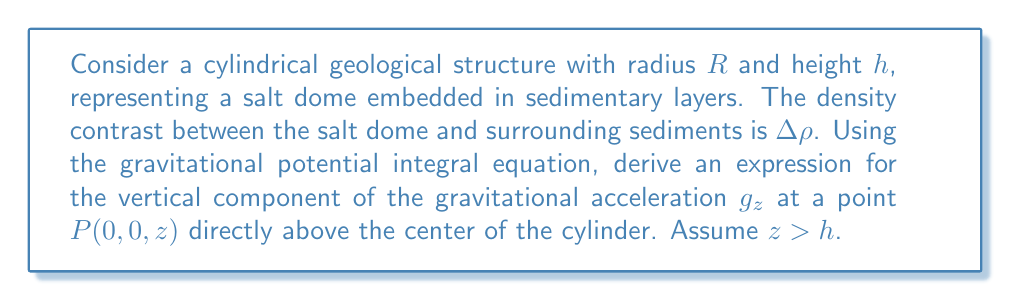Give your solution to this math problem. 1) The gravitational potential $U$ at point $P$ due to a mass distribution is given by:

   $$U = G \int_V \frac{\Delta\rho}{r} dV$$

   where $G$ is the gravitational constant, $V$ is the volume of the cylinder, and $r$ is the distance from a point in the cylinder to $P$.

2) For a cylinder, we can use cylindrical coordinates $(r', \theta, z')$:

   $$U = G\Delta\rho \int_0^h \int_0^R \int_0^{2\pi} \frac{r'}{[(z-z')^2 + r'^2]^{1/2}} d\theta dr' dz'$$

3) The vertical component of gravitational acceleration $g_z$ is given by:

   $$g_z = -\frac{\partial U}{\partial z}$$

4) Differentiating under the integral sign:

   $$g_z = G\Delta\rho \int_0^h \int_0^R \int_0^{2\pi} \frac{z-z'}{[(z-z')^2 + r'^2]^{3/2}} r' d\theta dr' dz'$$

5) Integrate with respect to $\theta$:

   $$g_z = 2\pi G\Delta\rho \int_0^h \int_0^R \frac{z-z'}{[(z-z')^2 + r'^2]^{3/2}} r' dr' dz'$$

6) Integrate with respect to $r'$:

   $$g_z = 2\pi G\Delta\rho \int_0^h \left[1 - \frac{z-z'}{\sqrt{(z-z')^2 + R^2}}\right] dz'$$

7) Finally, integrate with respect to $z'$:

   $$g_z = 2\pi G\Delta\rho \left[z - h - \sqrt{(z-h)^2 + R^2} + \sqrt{z^2 + R^2}\right]$$

This is the expression for the vertical component of gravitational acceleration at point $P(0,0,z)$ above the center of the cylindrical salt dome.
Answer: $$g_z = 2\pi G\Delta\rho \left[z - h - \sqrt{(z-h)^2 + R^2} + \sqrt{z^2 + R^2}\right]$$ 